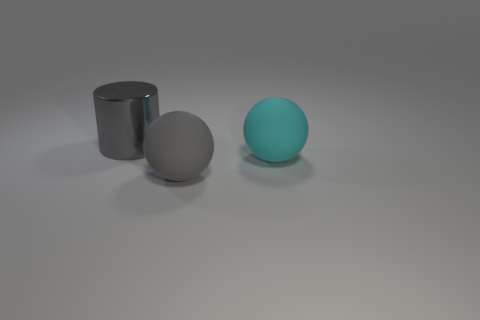There is a object that is on the left side of the cyan rubber thing and behind the big gray ball; what shape is it?
Your response must be concise. Cylinder. What number of objects are things that are right of the large gray shiny cylinder or cylinders behind the cyan rubber object?
Your response must be concise. 3. What number of gray objects are cylinders or large rubber balls?
Give a very brief answer. 2. What material is the big object that is both behind the big gray matte object and in front of the big metal thing?
Provide a short and direct response. Rubber. Is the material of the big cylinder the same as the cyan ball?
Your answer should be compact. No. What number of blue spheres are the same size as the gray shiny cylinder?
Offer a very short reply. 0. Are there an equal number of large objects that are in front of the large gray matte thing and cyan matte balls?
Your answer should be very brief. No. What number of big gray things are on the left side of the big gray sphere and in front of the large metal thing?
Offer a very short reply. 0. There is a gray object that is to the right of the metal object; is it the same shape as the gray shiny object?
Ensure brevity in your answer.  No. There is a gray object that is the same size as the gray cylinder; what material is it?
Provide a short and direct response. Rubber. 